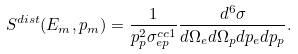<formula> <loc_0><loc_0><loc_500><loc_500>S ^ { d i s t } ( E _ { m } , p _ { m } ) = \frac { 1 } { p ^ { 2 } _ { p } \sigma _ { e p } ^ { c c 1 } } \frac { d ^ { 6 } \sigma } { d \Omega _ { e } d \Omega _ { p } d p _ { e } d p _ { p } } .</formula> 